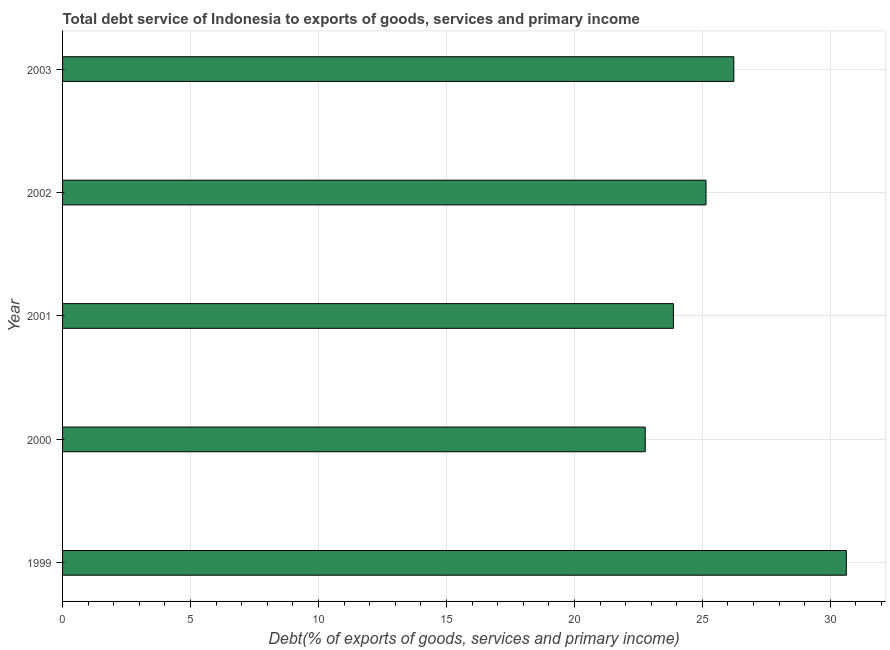Does the graph contain grids?
Make the answer very short. Yes. What is the title of the graph?
Your answer should be compact. Total debt service of Indonesia to exports of goods, services and primary income. What is the label or title of the X-axis?
Ensure brevity in your answer.  Debt(% of exports of goods, services and primary income). What is the total debt service in 2003?
Offer a terse response. 26.23. Across all years, what is the maximum total debt service?
Offer a terse response. 30.62. Across all years, what is the minimum total debt service?
Provide a short and direct response. 22.77. In which year was the total debt service maximum?
Keep it short and to the point. 1999. In which year was the total debt service minimum?
Provide a short and direct response. 2000. What is the sum of the total debt service?
Offer a very short reply. 128.63. What is the difference between the total debt service in 2002 and 2003?
Offer a very short reply. -1.09. What is the average total debt service per year?
Offer a terse response. 25.73. What is the median total debt service?
Keep it short and to the point. 25.14. Do a majority of the years between 1999 and 2003 (inclusive) have total debt service greater than 14 %?
Offer a terse response. Yes. What is the ratio of the total debt service in 1999 to that in 2000?
Your response must be concise. 1.34. Is the total debt service in 1999 less than that in 2002?
Your answer should be very brief. No. Is the difference between the total debt service in 2002 and 2003 greater than the difference between any two years?
Give a very brief answer. No. What is the difference between the highest and the second highest total debt service?
Your response must be concise. 4.39. What is the difference between the highest and the lowest total debt service?
Give a very brief answer. 7.86. Are all the bars in the graph horizontal?
Your answer should be very brief. Yes. How many years are there in the graph?
Your response must be concise. 5. Are the values on the major ticks of X-axis written in scientific E-notation?
Your response must be concise. No. What is the Debt(% of exports of goods, services and primary income) of 1999?
Your answer should be compact. 30.62. What is the Debt(% of exports of goods, services and primary income) in 2000?
Your answer should be very brief. 22.77. What is the Debt(% of exports of goods, services and primary income) in 2001?
Your answer should be very brief. 23.87. What is the Debt(% of exports of goods, services and primary income) in 2002?
Offer a very short reply. 25.14. What is the Debt(% of exports of goods, services and primary income) of 2003?
Provide a succinct answer. 26.23. What is the difference between the Debt(% of exports of goods, services and primary income) in 1999 and 2000?
Give a very brief answer. 7.86. What is the difference between the Debt(% of exports of goods, services and primary income) in 1999 and 2001?
Provide a succinct answer. 6.76. What is the difference between the Debt(% of exports of goods, services and primary income) in 1999 and 2002?
Give a very brief answer. 5.48. What is the difference between the Debt(% of exports of goods, services and primary income) in 1999 and 2003?
Keep it short and to the point. 4.39. What is the difference between the Debt(% of exports of goods, services and primary income) in 2000 and 2001?
Offer a very short reply. -1.1. What is the difference between the Debt(% of exports of goods, services and primary income) in 2000 and 2002?
Provide a short and direct response. -2.37. What is the difference between the Debt(% of exports of goods, services and primary income) in 2000 and 2003?
Your answer should be compact. -3.46. What is the difference between the Debt(% of exports of goods, services and primary income) in 2001 and 2002?
Offer a very short reply. -1.27. What is the difference between the Debt(% of exports of goods, services and primary income) in 2001 and 2003?
Provide a short and direct response. -2.36. What is the difference between the Debt(% of exports of goods, services and primary income) in 2002 and 2003?
Provide a short and direct response. -1.09. What is the ratio of the Debt(% of exports of goods, services and primary income) in 1999 to that in 2000?
Your answer should be very brief. 1.34. What is the ratio of the Debt(% of exports of goods, services and primary income) in 1999 to that in 2001?
Offer a very short reply. 1.28. What is the ratio of the Debt(% of exports of goods, services and primary income) in 1999 to that in 2002?
Provide a short and direct response. 1.22. What is the ratio of the Debt(% of exports of goods, services and primary income) in 1999 to that in 2003?
Give a very brief answer. 1.17. What is the ratio of the Debt(% of exports of goods, services and primary income) in 2000 to that in 2001?
Make the answer very short. 0.95. What is the ratio of the Debt(% of exports of goods, services and primary income) in 2000 to that in 2002?
Ensure brevity in your answer.  0.91. What is the ratio of the Debt(% of exports of goods, services and primary income) in 2000 to that in 2003?
Offer a very short reply. 0.87. What is the ratio of the Debt(% of exports of goods, services and primary income) in 2001 to that in 2002?
Your response must be concise. 0.95. What is the ratio of the Debt(% of exports of goods, services and primary income) in 2001 to that in 2003?
Make the answer very short. 0.91. 